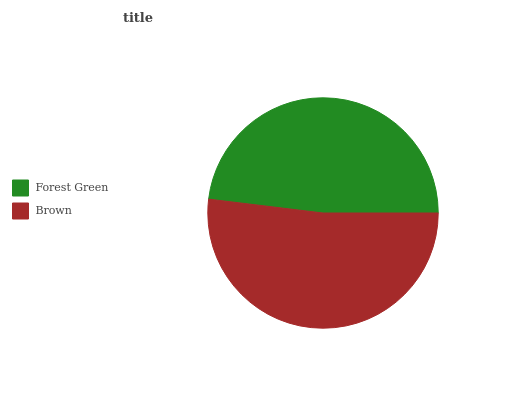Is Forest Green the minimum?
Answer yes or no. Yes. Is Brown the maximum?
Answer yes or no. Yes. Is Brown the minimum?
Answer yes or no. No. Is Brown greater than Forest Green?
Answer yes or no. Yes. Is Forest Green less than Brown?
Answer yes or no. Yes. Is Forest Green greater than Brown?
Answer yes or no. No. Is Brown less than Forest Green?
Answer yes or no. No. Is Brown the high median?
Answer yes or no. Yes. Is Forest Green the low median?
Answer yes or no. Yes. Is Forest Green the high median?
Answer yes or no. No. Is Brown the low median?
Answer yes or no. No. 